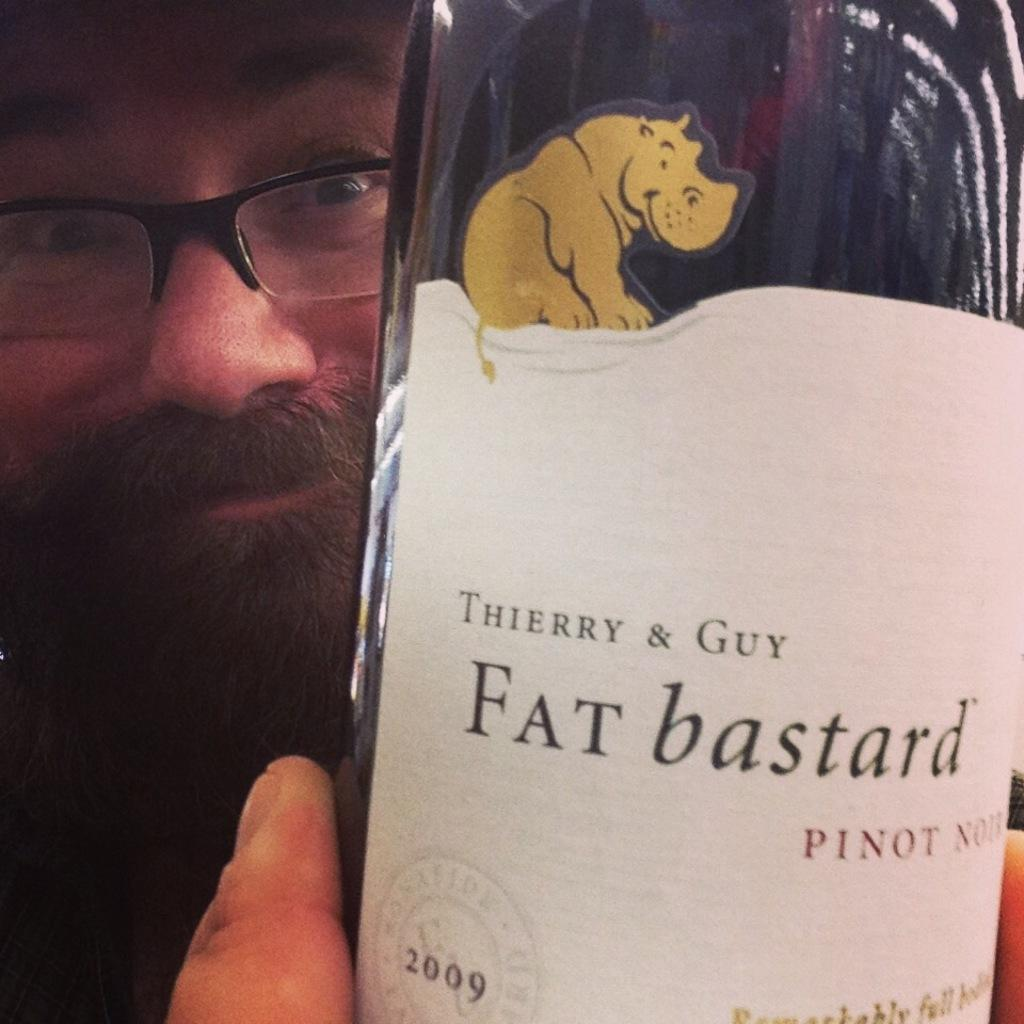What is present in the image? There is a man in the image. What is the man holding in the image? The man is holding a bottle. What type of force is being exerted by the bird on the pen in the image? There is no bird or pen present in the image, so it is not possible to determine what type of force might be exerted. 